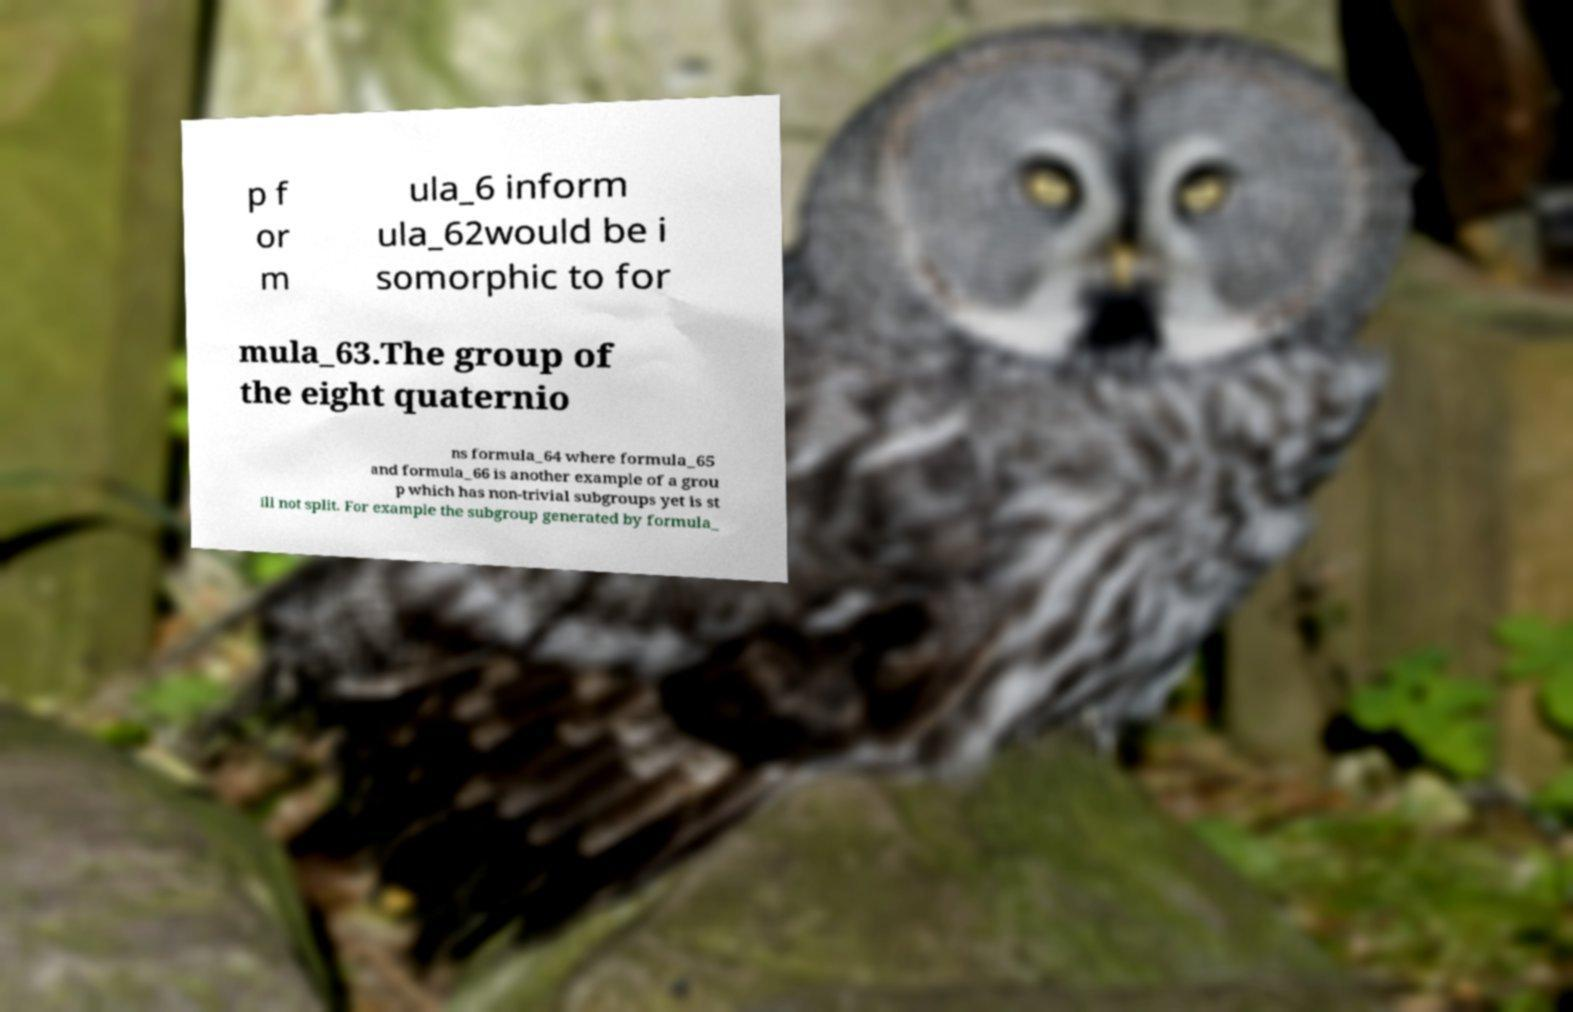There's text embedded in this image that I need extracted. Can you transcribe it verbatim? p f or m ula_6 inform ula_62would be i somorphic to for mula_63.The group of the eight quaternio ns formula_64 where formula_65 and formula_66 is another example of a grou p which has non-trivial subgroups yet is st ill not split. For example the subgroup generated by formula_ 